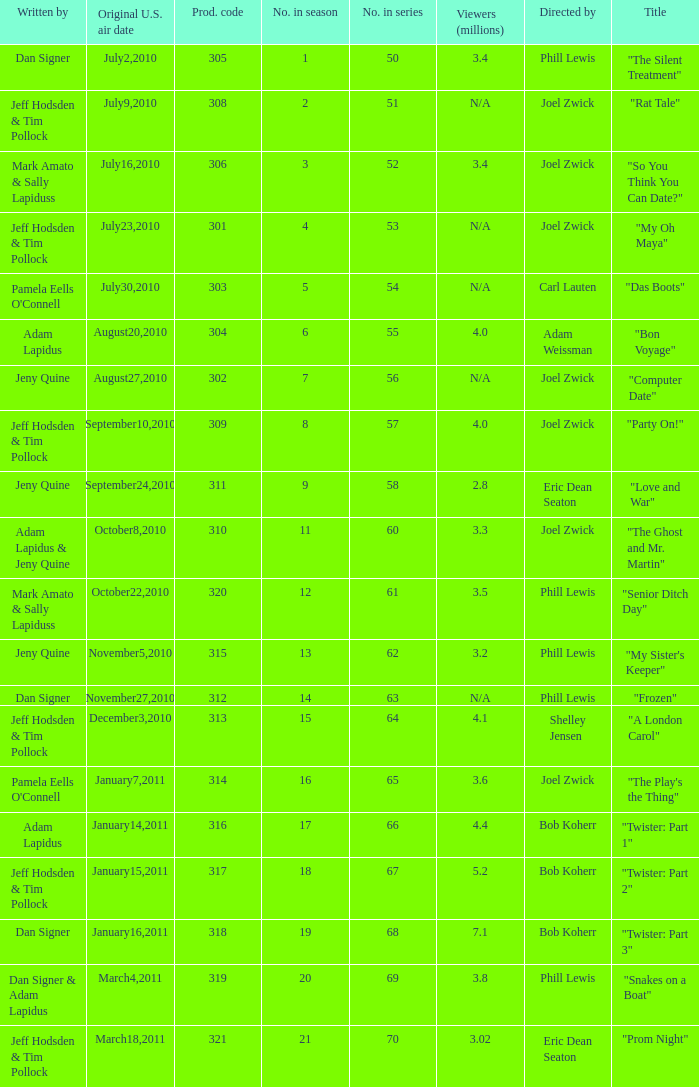Who was the directed for the episode titled "twister: part 1"? Bob Koherr. 